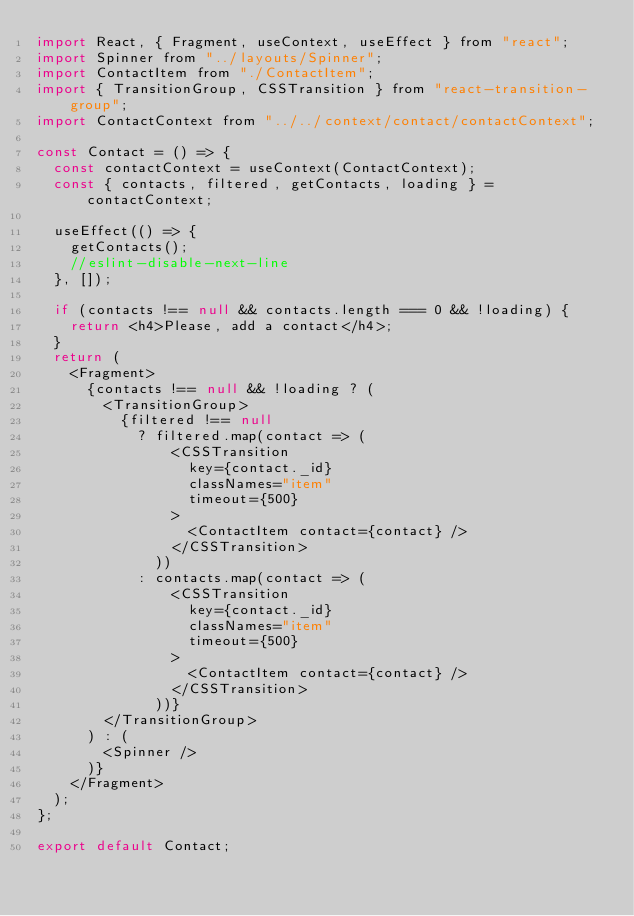Convert code to text. <code><loc_0><loc_0><loc_500><loc_500><_JavaScript_>import React, { Fragment, useContext, useEffect } from "react";
import Spinner from "../layouts/Spinner";
import ContactItem from "./ContactItem";
import { TransitionGroup, CSSTransition } from "react-transition-group";
import ContactContext from "../../context/contact/contactContext";

const Contact = () => {
  const contactContext = useContext(ContactContext);
  const { contacts, filtered, getContacts, loading } = contactContext;

  useEffect(() => {
    getContacts();
    //eslint-disable-next-line
  }, []);

  if (contacts !== null && contacts.length === 0 && !loading) {
    return <h4>Please, add a contact</h4>;
  }
  return (
    <Fragment>
      {contacts !== null && !loading ? (
        <TransitionGroup>
          {filtered !== null
            ? filtered.map(contact => (
                <CSSTransition
                  key={contact._id}
                  classNames="item"
                  timeout={500}
                >
                  <ContactItem contact={contact} />
                </CSSTransition>
              ))
            : contacts.map(contact => (
                <CSSTransition
                  key={contact._id}
                  classNames="item"
                  timeout={500}
                >
                  <ContactItem contact={contact} />
                </CSSTransition>
              ))}
        </TransitionGroup>
      ) : (
        <Spinner />
      )}
    </Fragment>
  );
};

export default Contact;
</code> 